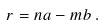<formula> <loc_0><loc_0><loc_500><loc_500>r = n a - m b \, .</formula> 